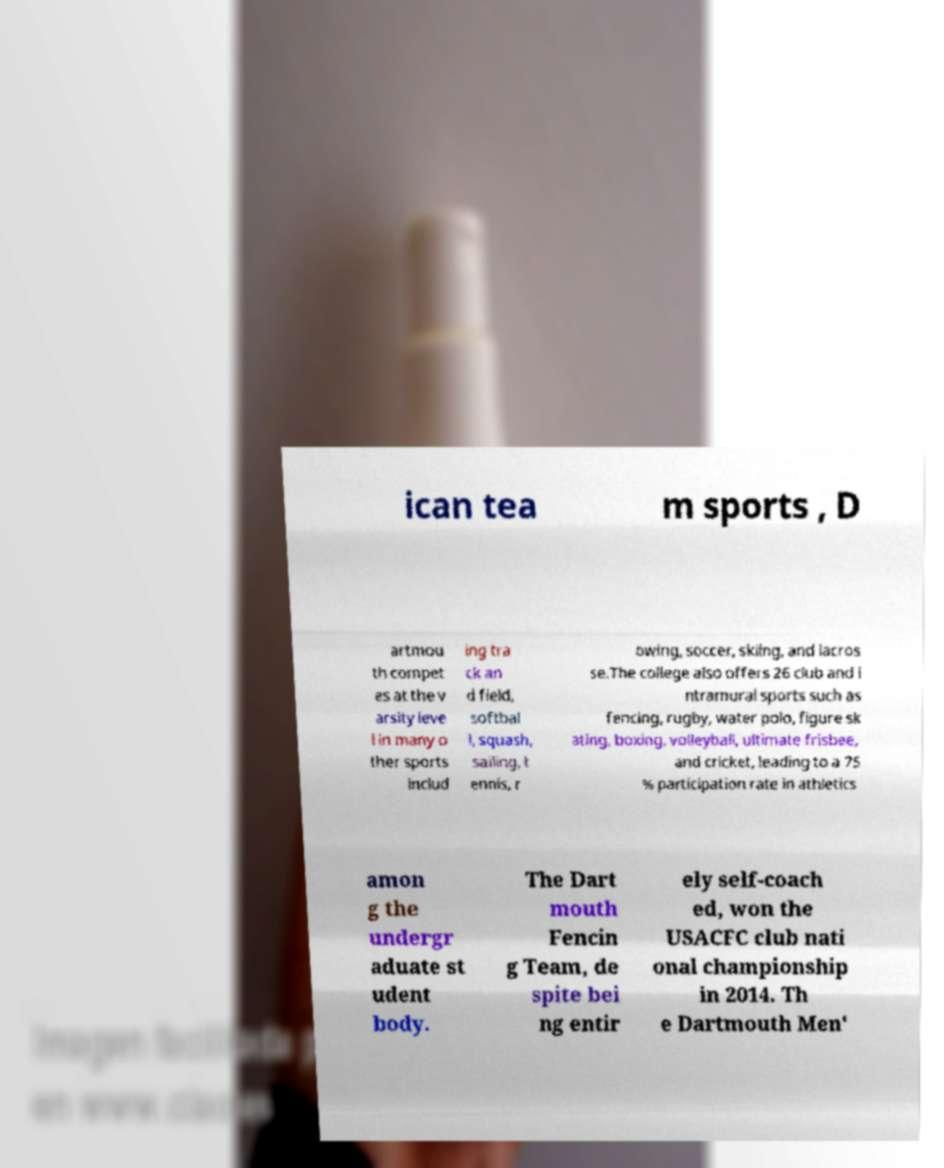Can you accurately transcribe the text from the provided image for me? ican tea m sports , D artmou th compet es at the v arsity leve l in many o ther sports includ ing tra ck an d field, softbal l, squash, sailing, t ennis, r owing, soccer, skiing, and lacros se.The college also offers 26 club and i ntramural sports such as fencing, rugby, water polo, figure sk ating, boxing, volleyball, ultimate frisbee, and cricket, leading to a 75 % participation rate in athletics amon g the undergr aduate st udent body. The Dart mouth Fencin g Team, de spite bei ng entir ely self-coach ed, won the USACFC club nati onal championship in 2014. Th e Dartmouth Men' 